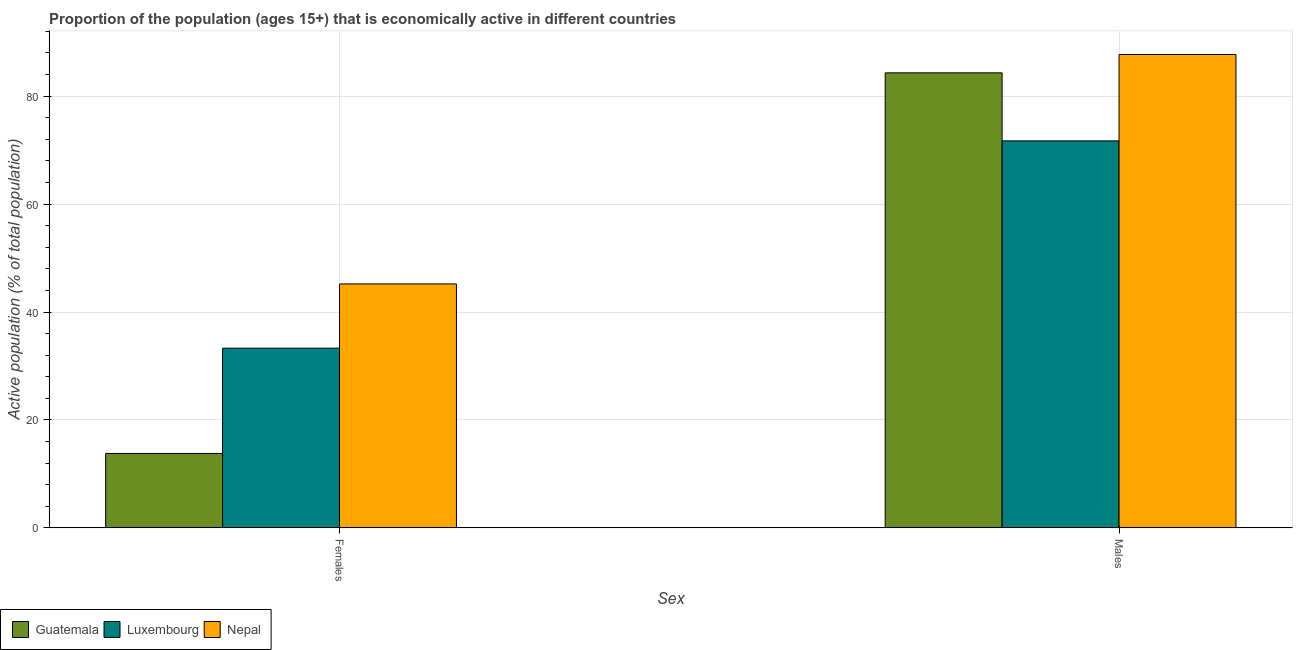How many groups of bars are there?
Give a very brief answer. 2. Are the number of bars per tick equal to the number of legend labels?
Your answer should be very brief. Yes. Are the number of bars on each tick of the X-axis equal?
Ensure brevity in your answer.  Yes. What is the label of the 1st group of bars from the left?
Make the answer very short. Females. What is the percentage of economically active male population in Nepal?
Provide a succinct answer. 87.7. Across all countries, what is the maximum percentage of economically active male population?
Keep it short and to the point. 87.7. Across all countries, what is the minimum percentage of economically active male population?
Your response must be concise. 71.7. In which country was the percentage of economically active female population maximum?
Your answer should be compact. Nepal. In which country was the percentage of economically active female population minimum?
Your response must be concise. Guatemala. What is the total percentage of economically active male population in the graph?
Your answer should be compact. 243.7. What is the difference between the percentage of economically active female population in Luxembourg and that in Guatemala?
Your response must be concise. 19.5. What is the difference between the percentage of economically active female population in Nepal and the percentage of economically active male population in Luxembourg?
Your response must be concise. -26.5. What is the average percentage of economically active female population per country?
Keep it short and to the point. 30.77. What is the difference between the percentage of economically active male population and percentage of economically active female population in Luxembourg?
Your answer should be compact. 38.4. In how many countries, is the percentage of economically active male population greater than 28 %?
Ensure brevity in your answer.  3. What is the ratio of the percentage of economically active female population in Luxembourg to that in Nepal?
Your answer should be very brief. 0.74. Is the percentage of economically active female population in Luxembourg less than that in Guatemala?
Your answer should be compact. No. In how many countries, is the percentage of economically active male population greater than the average percentage of economically active male population taken over all countries?
Make the answer very short. 2. What does the 2nd bar from the left in Males represents?
Give a very brief answer. Luxembourg. What does the 1st bar from the right in Females represents?
Your answer should be very brief. Nepal. How many bars are there?
Keep it short and to the point. 6. Are all the bars in the graph horizontal?
Offer a terse response. No. Are the values on the major ticks of Y-axis written in scientific E-notation?
Your answer should be very brief. No. Where does the legend appear in the graph?
Your response must be concise. Bottom left. What is the title of the graph?
Keep it short and to the point. Proportion of the population (ages 15+) that is economically active in different countries. What is the label or title of the X-axis?
Offer a terse response. Sex. What is the label or title of the Y-axis?
Make the answer very short. Active population (% of total population). What is the Active population (% of total population) in Guatemala in Females?
Offer a terse response. 13.8. What is the Active population (% of total population) of Luxembourg in Females?
Keep it short and to the point. 33.3. What is the Active population (% of total population) in Nepal in Females?
Your answer should be very brief. 45.2. What is the Active population (% of total population) in Guatemala in Males?
Your answer should be very brief. 84.3. What is the Active population (% of total population) of Luxembourg in Males?
Provide a short and direct response. 71.7. What is the Active population (% of total population) in Nepal in Males?
Keep it short and to the point. 87.7. Across all Sex, what is the maximum Active population (% of total population) of Guatemala?
Offer a very short reply. 84.3. Across all Sex, what is the maximum Active population (% of total population) in Luxembourg?
Keep it short and to the point. 71.7. Across all Sex, what is the maximum Active population (% of total population) of Nepal?
Give a very brief answer. 87.7. Across all Sex, what is the minimum Active population (% of total population) of Guatemala?
Give a very brief answer. 13.8. Across all Sex, what is the minimum Active population (% of total population) of Luxembourg?
Your response must be concise. 33.3. Across all Sex, what is the minimum Active population (% of total population) in Nepal?
Offer a terse response. 45.2. What is the total Active population (% of total population) in Guatemala in the graph?
Your response must be concise. 98.1. What is the total Active population (% of total population) in Luxembourg in the graph?
Offer a terse response. 105. What is the total Active population (% of total population) of Nepal in the graph?
Ensure brevity in your answer.  132.9. What is the difference between the Active population (% of total population) of Guatemala in Females and that in Males?
Provide a short and direct response. -70.5. What is the difference between the Active population (% of total population) of Luxembourg in Females and that in Males?
Keep it short and to the point. -38.4. What is the difference between the Active population (% of total population) in Nepal in Females and that in Males?
Your response must be concise. -42.5. What is the difference between the Active population (% of total population) of Guatemala in Females and the Active population (% of total population) of Luxembourg in Males?
Offer a terse response. -57.9. What is the difference between the Active population (% of total population) of Guatemala in Females and the Active population (% of total population) of Nepal in Males?
Make the answer very short. -73.9. What is the difference between the Active population (% of total population) of Luxembourg in Females and the Active population (% of total population) of Nepal in Males?
Provide a short and direct response. -54.4. What is the average Active population (% of total population) in Guatemala per Sex?
Offer a terse response. 49.05. What is the average Active population (% of total population) in Luxembourg per Sex?
Give a very brief answer. 52.5. What is the average Active population (% of total population) of Nepal per Sex?
Offer a terse response. 66.45. What is the difference between the Active population (% of total population) of Guatemala and Active population (% of total population) of Luxembourg in Females?
Give a very brief answer. -19.5. What is the difference between the Active population (% of total population) of Guatemala and Active population (% of total population) of Nepal in Females?
Offer a terse response. -31.4. What is the difference between the Active population (% of total population) in Guatemala and Active population (% of total population) in Luxembourg in Males?
Provide a short and direct response. 12.6. What is the difference between the Active population (% of total population) of Guatemala and Active population (% of total population) of Nepal in Males?
Your answer should be very brief. -3.4. What is the ratio of the Active population (% of total population) of Guatemala in Females to that in Males?
Give a very brief answer. 0.16. What is the ratio of the Active population (% of total population) in Luxembourg in Females to that in Males?
Your answer should be very brief. 0.46. What is the ratio of the Active population (% of total population) in Nepal in Females to that in Males?
Keep it short and to the point. 0.52. What is the difference between the highest and the second highest Active population (% of total population) of Guatemala?
Offer a terse response. 70.5. What is the difference between the highest and the second highest Active population (% of total population) of Luxembourg?
Give a very brief answer. 38.4. What is the difference between the highest and the second highest Active population (% of total population) in Nepal?
Offer a terse response. 42.5. What is the difference between the highest and the lowest Active population (% of total population) in Guatemala?
Your answer should be compact. 70.5. What is the difference between the highest and the lowest Active population (% of total population) in Luxembourg?
Make the answer very short. 38.4. What is the difference between the highest and the lowest Active population (% of total population) in Nepal?
Make the answer very short. 42.5. 